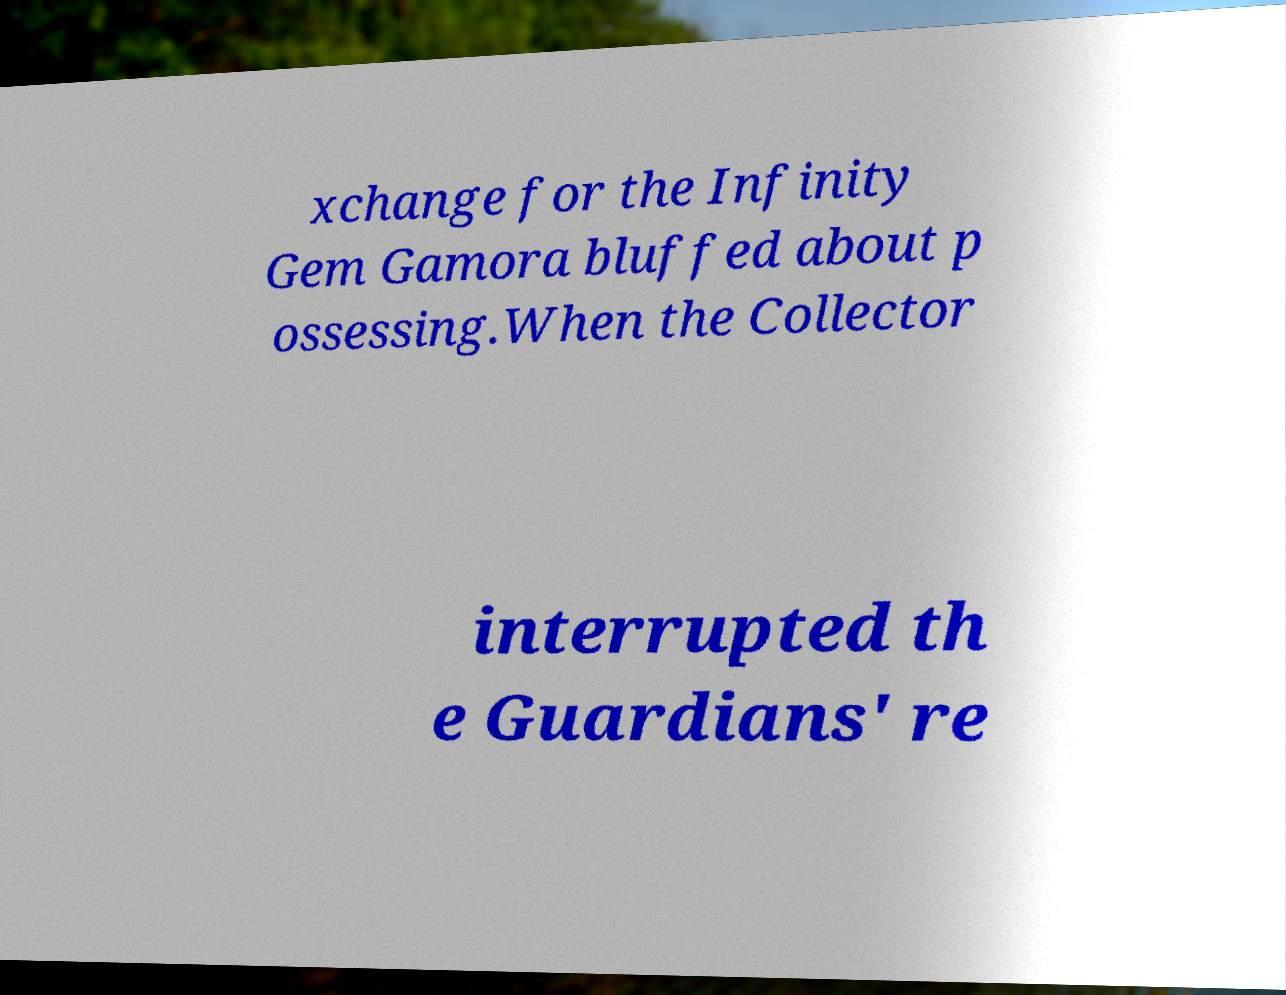Could you assist in decoding the text presented in this image and type it out clearly? xchange for the Infinity Gem Gamora bluffed about p ossessing.When the Collector interrupted th e Guardians' re 